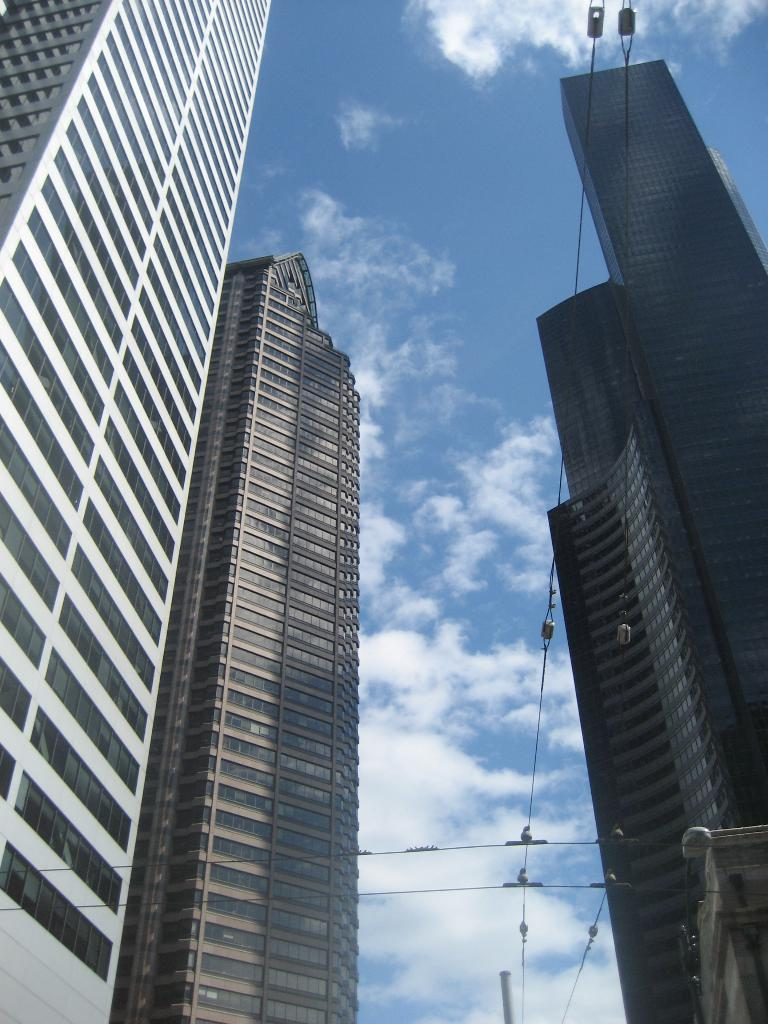What type of structures are visible in the image? There are buildings in the image. What else can be seen in the image besides the buildings? There is a pole in the image. How would you describe the sky in the image? The sky is blue and cloudy in the image. How many passengers are waiting for the machine to arrive in the image? There is no reference to passengers or a machine in the image, so it is not possible to answer that question. 